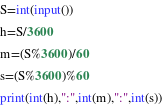Convert code to text. <code><loc_0><loc_0><loc_500><loc_500><_Python_>S=int(input())
h=S/3600
m=(S%3600)/60
s=(S%3600)%60
print(int(h),":",int(m),":",int(s))</code> 